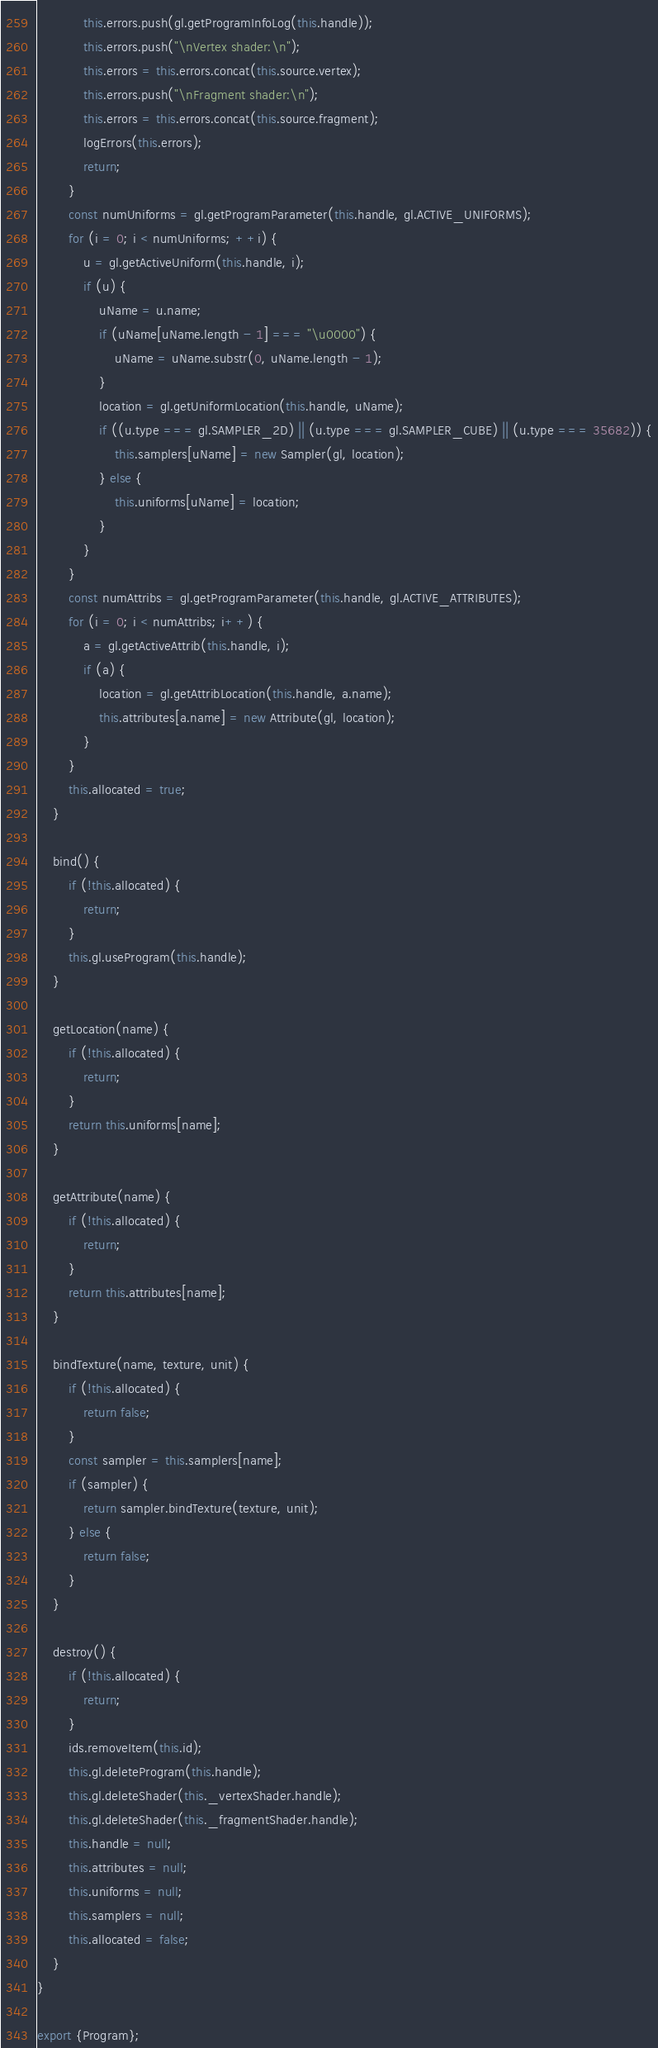<code> <loc_0><loc_0><loc_500><loc_500><_JavaScript_>            this.errors.push(gl.getProgramInfoLog(this.handle));
            this.errors.push("\nVertex shader:\n");
            this.errors = this.errors.concat(this.source.vertex);
            this.errors.push("\nFragment shader:\n");
            this.errors = this.errors.concat(this.source.fragment);
            logErrors(this.errors);
            return;
        }
        const numUniforms = gl.getProgramParameter(this.handle, gl.ACTIVE_UNIFORMS);
        for (i = 0; i < numUniforms; ++i) {
            u = gl.getActiveUniform(this.handle, i);
            if (u) {
                uName = u.name;
                if (uName[uName.length - 1] === "\u0000") {
                    uName = uName.substr(0, uName.length - 1);
                }
                location = gl.getUniformLocation(this.handle, uName);
                if ((u.type === gl.SAMPLER_2D) || (u.type === gl.SAMPLER_CUBE) || (u.type === 35682)) {
                    this.samplers[uName] = new Sampler(gl, location);
                } else {
                    this.uniforms[uName] = location;
                }
            }
        }
        const numAttribs = gl.getProgramParameter(this.handle, gl.ACTIVE_ATTRIBUTES);
        for (i = 0; i < numAttribs; i++) {
            a = gl.getActiveAttrib(this.handle, i);
            if (a) {
                location = gl.getAttribLocation(this.handle, a.name);
                this.attributes[a.name] = new Attribute(gl, location);
            }
        }
        this.allocated = true;
    }

    bind() {
        if (!this.allocated) {
            return;
        }
        this.gl.useProgram(this.handle);
    }

    getLocation(name) {
        if (!this.allocated) {
            return;
        }
        return this.uniforms[name];
    }

    getAttribute(name) {
        if (!this.allocated) {
            return;
        }
        return this.attributes[name];
    }

    bindTexture(name, texture, unit) {
        if (!this.allocated) {
            return false;
        }
        const sampler = this.samplers[name];
        if (sampler) {
            return sampler.bindTexture(texture, unit);
        } else {
            return false;
        }
    }

    destroy() {
        if (!this.allocated) {
            return;
        }
        ids.removeItem(this.id);
        this.gl.deleteProgram(this.handle);
        this.gl.deleteShader(this._vertexShader.handle);
        this.gl.deleteShader(this._fragmentShader.handle);
        this.handle = null;
        this.attributes = null;
        this.uniforms = null;
        this.samplers = null;
        this.allocated = false;
    }
}

export {Program};</code> 